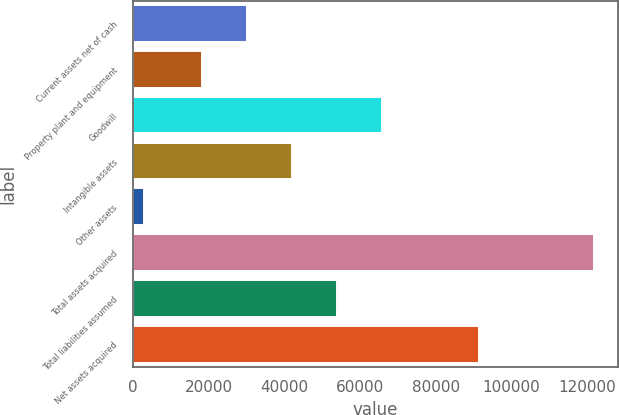Convert chart. <chart><loc_0><loc_0><loc_500><loc_500><bar_chart><fcel>Current assets net of cash<fcel>Property plant and equipment<fcel>Goodwill<fcel>Intangible assets<fcel>Other assets<fcel>Total assets acquired<fcel>Total liabilities assumed<fcel>Net assets acquired<nl><fcel>30235.7<fcel>18344<fcel>65910.8<fcel>42127.4<fcel>2950<fcel>121867<fcel>54019.1<fcel>91286<nl></chart> 